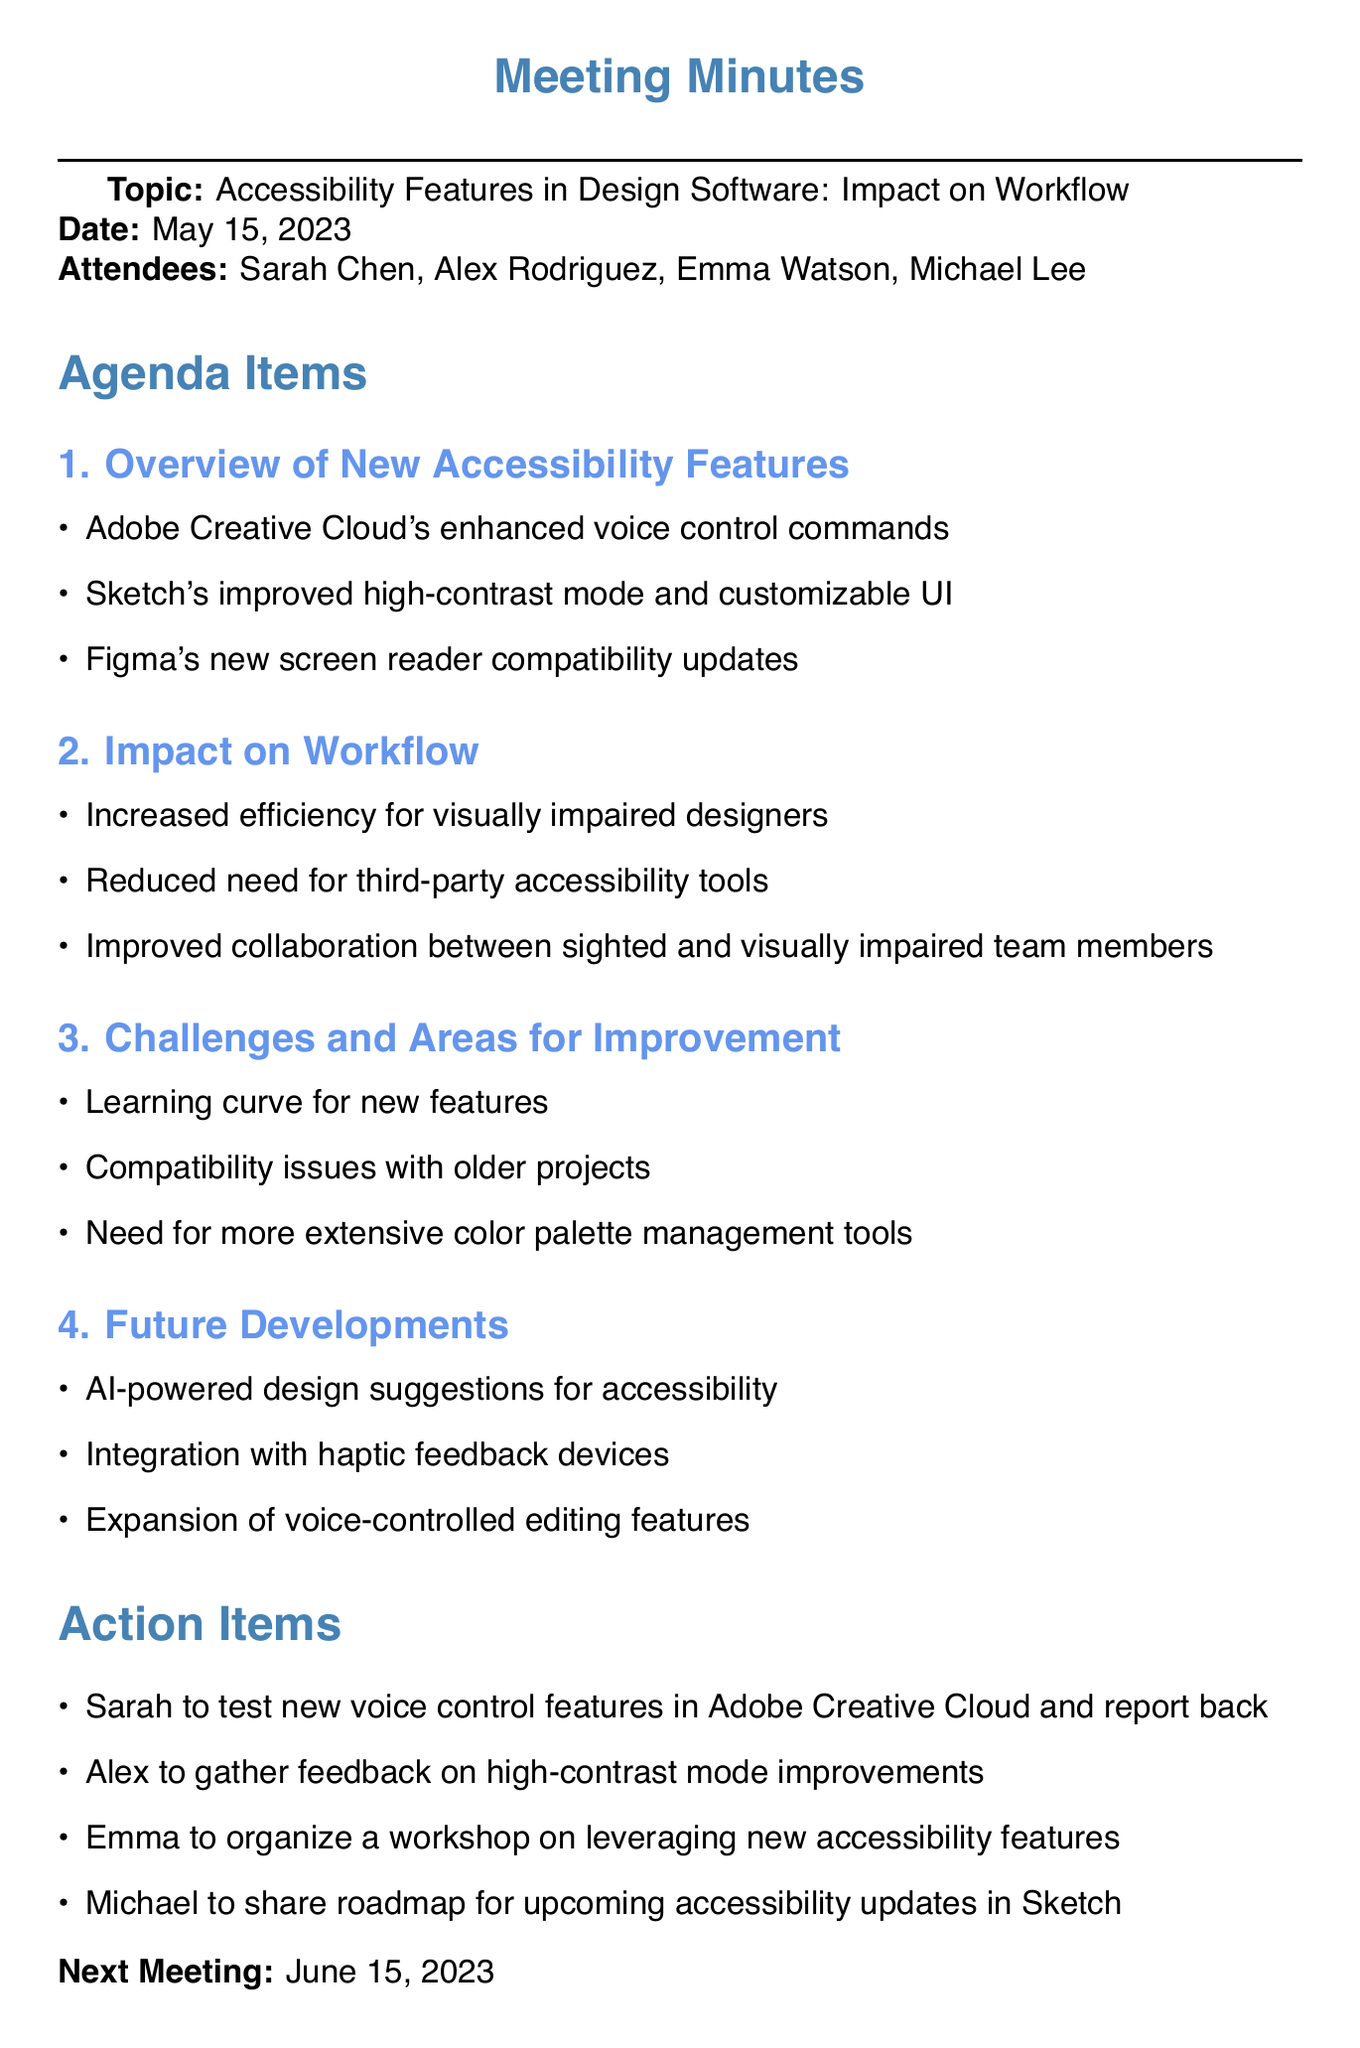What is the date of the meeting? The date of the meeting is stated explicitly in the document as May 15, 2023.
Answer: May 15, 2023 Who is the Accessibility Specialist attending the meeting? The document lists Emma Watson as the Accessibility Specialist who attended the meeting.
Answer: Emma Watson What is one of the new features in Adobe Creative Cloud? The document highlights Adobe Creative Cloud's enhanced voice control commands as a new feature discussed.
Answer: Enhanced voice control commands What is the next meeting date? The next meeting date is provided in the document as June 15, 2023.
Answer: June 15, 2023 What is a challenge mentioned regarding the new accessibility features? The document notes the learning curve for new features as one of the challenges faced.
Answer: Learning curve for new features Which software has improved high-contrast mode? The agenda item specifies that Sketch has improved its high-contrast mode.
Answer: Sketch What is one future development mentioned in the meeting? The document states that AI-powered design suggestions for accessibility is one of the future developments discussed.
Answer: AI-powered design suggestions for accessibility Why is there improved collaboration noted? The document mentions improved collaboration between sighted and visually impaired team members as an impact of the new features.
Answer: Improved collaboration between sighted and visually impaired team members 